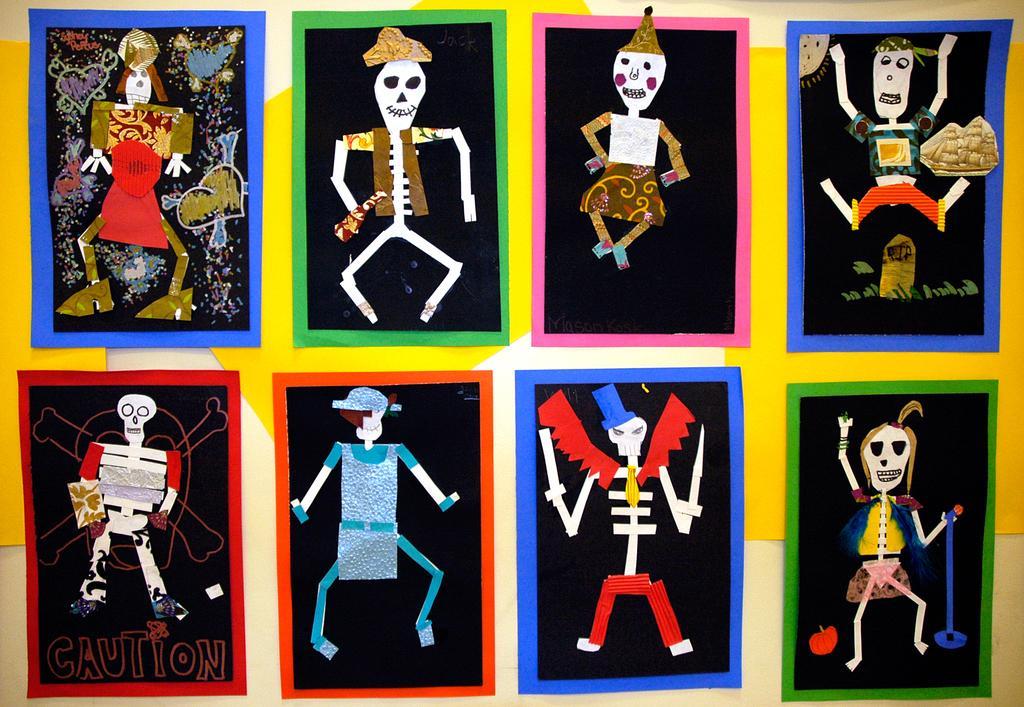Could you give a brief overview of what you see in this image? In this image, we can see there are eight posters having paintings. These posters are pasted on a surface, on which there are yellow color papers pasted. And the background is white in color. 